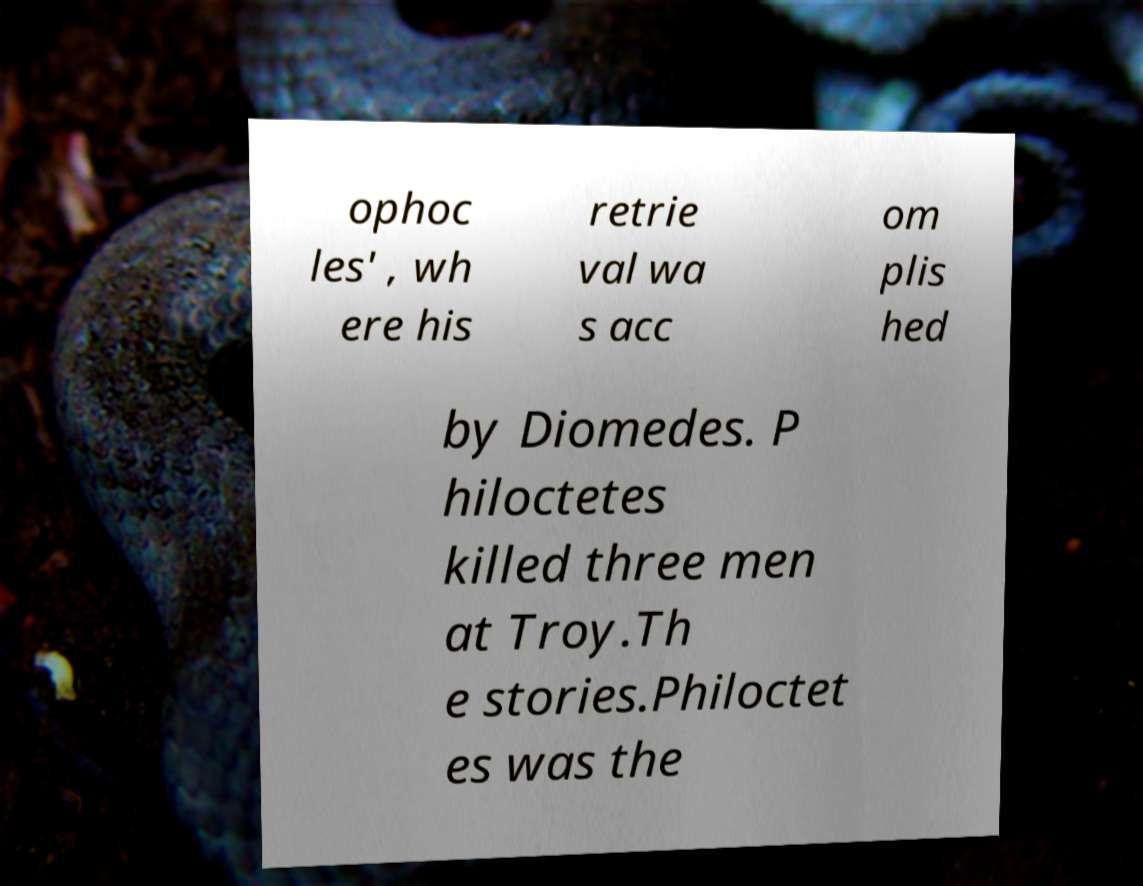Can you accurately transcribe the text from the provided image for me? ophoc les' , wh ere his retrie val wa s acc om plis hed by Diomedes. P hiloctetes killed three men at Troy.Th e stories.Philoctet es was the 